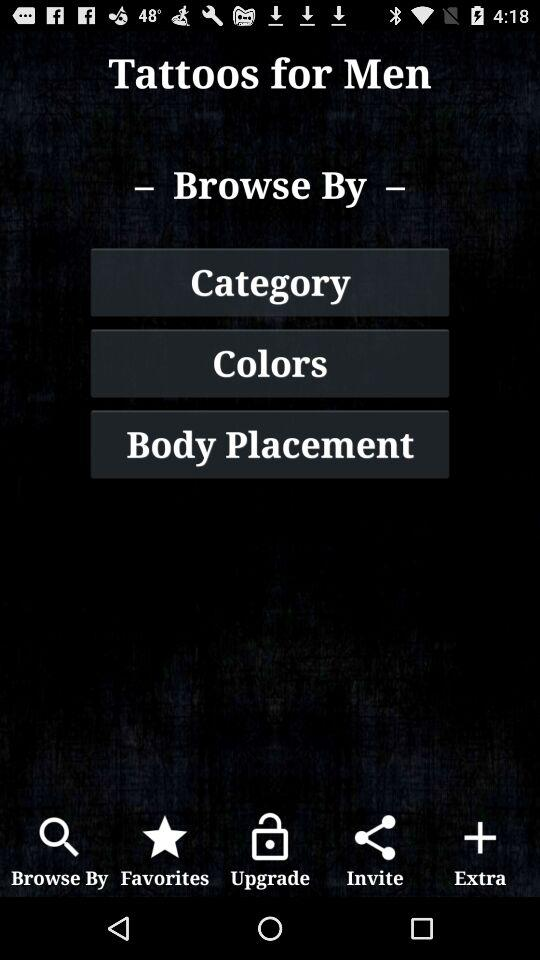How many tattoo colors are available?
When the provided information is insufficient, respond with <no answer>. <no answer> 